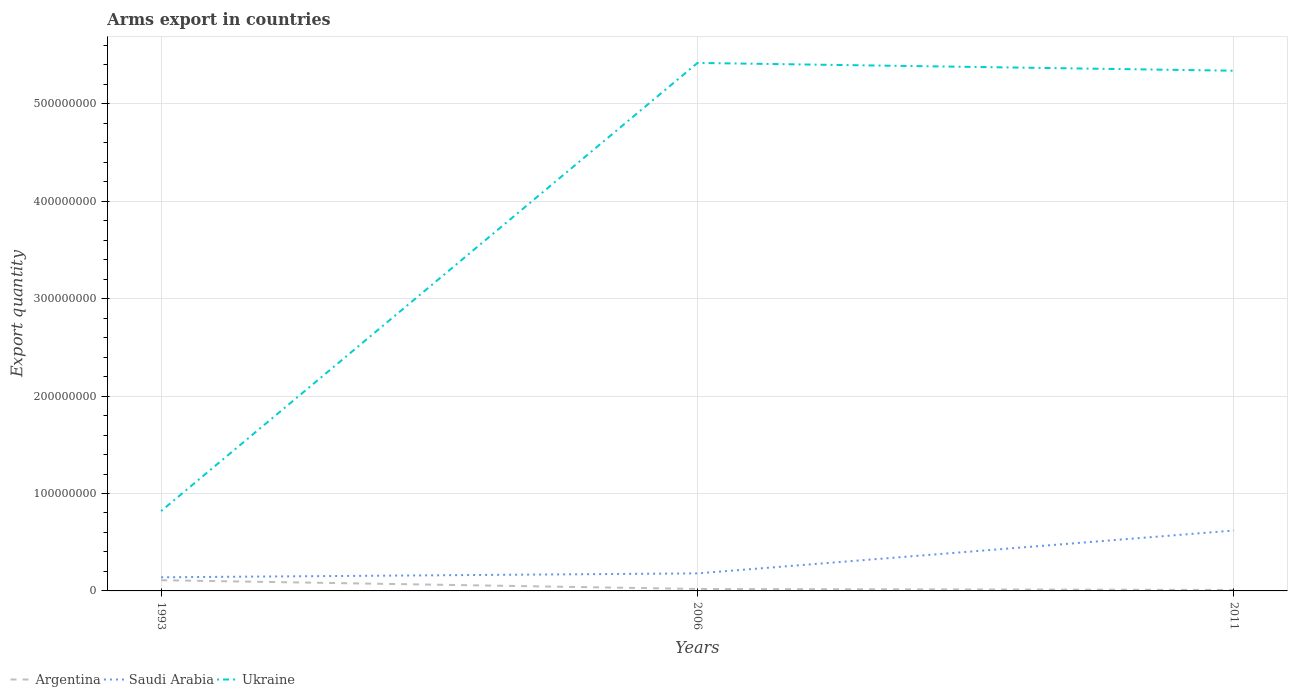How many different coloured lines are there?
Make the answer very short. 3. Across all years, what is the maximum total arms export in Saudi Arabia?
Give a very brief answer. 1.40e+07. What is the total total arms export in Saudi Arabia in the graph?
Provide a succinct answer. -4.80e+07. What is the difference between the highest and the lowest total arms export in Argentina?
Ensure brevity in your answer.  1. Is the total arms export in Saudi Arabia strictly greater than the total arms export in Ukraine over the years?
Provide a short and direct response. Yes. How many lines are there?
Offer a very short reply. 3. Are the values on the major ticks of Y-axis written in scientific E-notation?
Provide a short and direct response. No. Does the graph contain any zero values?
Make the answer very short. No. Does the graph contain grids?
Keep it short and to the point. Yes. Where does the legend appear in the graph?
Your answer should be compact. Bottom left. How many legend labels are there?
Your response must be concise. 3. What is the title of the graph?
Your answer should be compact. Arms export in countries. Does "Euro area" appear as one of the legend labels in the graph?
Ensure brevity in your answer.  No. What is the label or title of the X-axis?
Your response must be concise. Years. What is the label or title of the Y-axis?
Offer a very short reply. Export quantity. What is the Export quantity of Argentina in 1993?
Ensure brevity in your answer.  1.10e+07. What is the Export quantity of Saudi Arabia in 1993?
Offer a terse response. 1.40e+07. What is the Export quantity in Ukraine in 1993?
Your answer should be compact. 8.20e+07. What is the Export quantity in Argentina in 2006?
Your response must be concise. 2.00e+06. What is the Export quantity of Saudi Arabia in 2006?
Keep it short and to the point. 1.80e+07. What is the Export quantity in Ukraine in 2006?
Make the answer very short. 5.42e+08. What is the Export quantity of Saudi Arabia in 2011?
Your answer should be very brief. 6.20e+07. What is the Export quantity in Ukraine in 2011?
Offer a terse response. 5.34e+08. Across all years, what is the maximum Export quantity in Argentina?
Your response must be concise. 1.10e+07. Across all years, what is the maximum Export quantity in Saudi Arabia?
Offer a very short reply. 6.20e+07. Across all years, what is the maximum Export quantity in Ukraine?
Your response must be concise. 5.42e+08. Across all years, what is the minimum Export quantity in Argentina?
Provide a short and direct response. 1.00e+06. Across all years, what is the minimum Export quantity of Saudi Arabia?
Offer a very short reply. 1.40e+07. Across all years, what is the minimum Export quantity in Ukraine?
Keep it short and to the point. 8.20e+07. What is the total Export quantity in Argentina in the graph?
Your response must be concise. 1.40e+07. What is the total Export quantity of Saudi Arabia in the graph?
Keep it short and to the point. 9.40e+07. What is the total Export quantity in Ukraine in the graph?
Ensure brevity in your answer.  1.16e+09. What is the difference between the Export quantity of Argentina in 1993 and that in 2006?
Provide a succinct answer. 9.00e+06. What is the difference between the Export quantity in Saudi Arabia in 1993 and that in 2006?
Make the answer very short. -4.00e+06. What is the difference between the Export quantity of Ukraine in 1993 and that in 2006?
Make the answer very short. -4.60e+08. What is the difference between the Export quantity in Saudi Arabia in 1993 and that in 2011?
Your answer should be compact. -4.80e+07. What is the difference between the Export quantity in Ukraine in 1993 and that in 2011?
Make the answer very short. -4.52e+08. What is the difference between the Export quantity of Saudi Arabia in 2006 and that in 2011?
Provide a succinct answer. -4.40e+07. What is the difference between the Export quantity of Argentina in 1993 and the Export quantity of Saudi Arabia in 2006?
Provide a succinct answer. -7.00e+06. What is the difference between the Export quantity in Argentina in 1993 and the Export quantity in Ukraine in 2006?
Offer a very short reply. -5.31e+08. What is the difference between the Export quantity of Saudi Arabia in 1993 and the Export quantity of Ukraine in 2006?
Give a very brief answer. -5.28e+08. What is the difference between the Export quantity in Argentina in 1993 and the Export quantity in Saudi Arabia in 2011?
Your response must be concise. -5.10e+07. What is the difference between the Export quantity in Argentina in 1993 and the Export quantity in Ukraine in 2011?
Offer a terse response. -5.23e+08. What is the difference between the Export quantity of Saudi Arabia in 1993 and the Export quantity of Ukraine in 2011?
Give a very brief answer. -5.20e+08. What is the difference between the Export quantity of Argentina in 2006 and the Export quantity of Saudi Arabia in 2011?
Your answer should be compact. -6.00e+07. What is the difference between the Export quantity of Argentina in 2006 and the Export quantity of Ukraine in 2011?
Give a very brief answer. -5.32e+08. What is the difference between the Export quantity of Saudi Arabia in 2006 and the Export quantity of Ukraine in 2011?
Give a very brief answer. -5.16e+08. What is the average Export quantity in Argentina per year?
Offer a very short reply. 4.67e+06. What is the average Export quantity of Saudi Arabia per year?
Offer a very short reply. 3.13e+07. What is the average Export quantity in Ukraine per year?
Provide a short and direct response. 3.86e+08. In the year 1993, what is the difference between the Export quantity in Argentina and Export quantity in Saudi Arabia?
Your response must be concise. -3.00e+06. In the year 1993, what is the difference between the Export quantity in Argentina and Export quantity in Ukraine?
Provide a short and direct response. -7.10e+07. In the year 1993, what is the difference between the Export quantity of Saudi Arabia and Export quantity of Ukraine?
Your answer should be compact. -6.80e+07. In the year 2006, what is the difference between the Export quantity in Argentina and Export quantity in Saudi Arabia?
Provide a short and direct response. -1.60e+07. In the year 2006, what is the difference between the Export quantity in Argentina and Export quantity in Ukraine?
Make the answer very short. -5.40e+08. In the year 2006, what is the difference between the Export quantity of Saudi Arabia and Export quantity of Ukraine?
Your answer should be very brief. -5.24e+08. In the year 2011, what is the difference between the Export quantity of Argentina and Export quantity of Saudi Arabia?
Your response must be concise. -6.10e+07. In the year 2011, what is the difference between the Export quantity in Argentina and Export quantity in Ukraine?
Ensure brevity in your answer.  -5.33e+08. In the year 2011, what is the difference between the Export quantity of Saudi Arabia and Export quantity of Ukraine?
Give a very brief answer. -4.72e+08. What is the ratio of the Export quantity of Ukraine in 1993 to that in 2006?
Give a very brief answer. 0.15. What is the ratio of the Export quantity of Saudi Arabia in 1993 to that in 2011?
Provide a short and direct response. 0.23. What is the ratio of the Export quantity of Ukraine in 1993 to that in 2011?
Offer a very short reply. 0.15. What is the ratio of the Export quantity in Argentina in 2006 to that in 2011?
Provide a short and direct response. 2. What is the ratio of the Export quantity of Saudi Arabia in 2006 to that in 2011?
Keep it short and to the point. 0.29. What is the ratio of the Export quantity of Ukraine in 2006 to that in 2011?
Offer a very short reply. 1.01. What is the difference between the highest and the second highest Export quantity in Argentina?
Keep it short and to the point. 9.00e+06. What is the difference between the highest and the second highest Export quantity of Saudi Arabia?
Offer a terse response. 4.40e+07. What is the difference between the highest and the second highest Export quantity in Ukraine?
Your answer should be very brief. 8.00e+06. What is the difference between the highest and the lowest Export quantity of Argentina?
Provide a succinct answer. 1.00e+07. What is the difference between the highest and the lowest Export quantity of Saudi Arabia?
Keep it short and to the point. 4.80e+07. What is the difference between the highest and the lowest Export quantity of Ukraine?
Offer a terse response. 4.60e+08. 